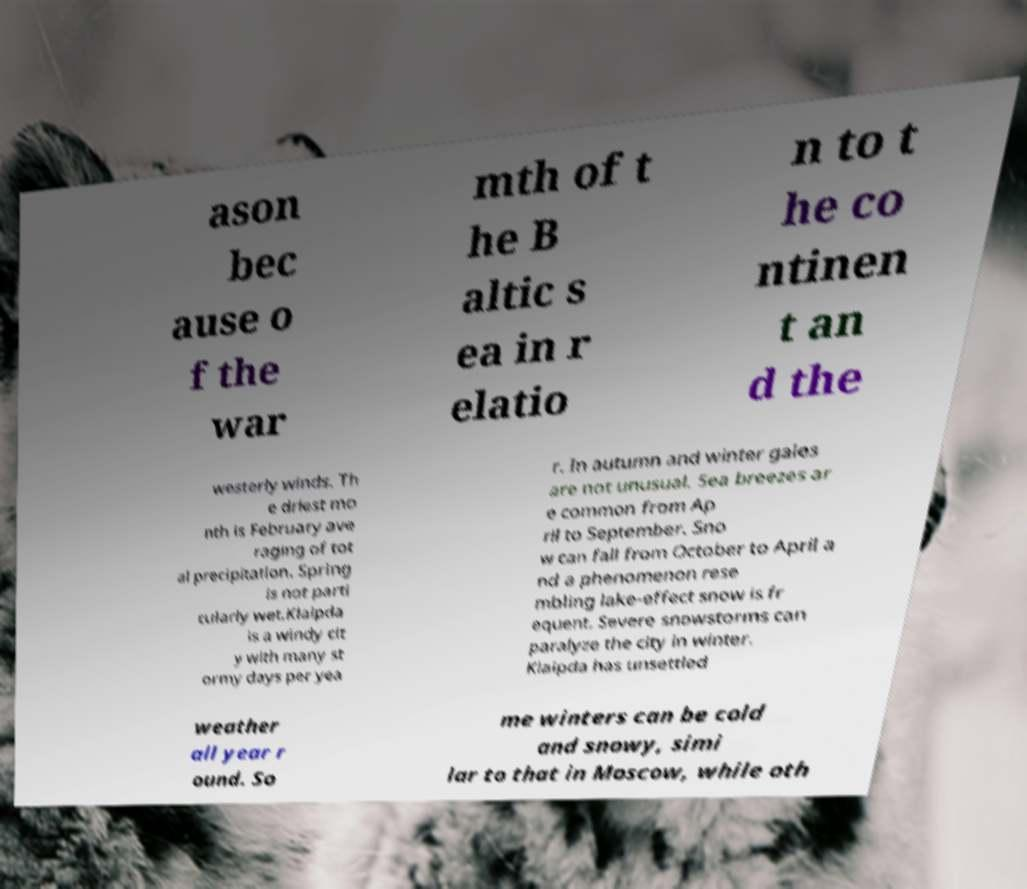Could you extract and type out the text from this image? ason bec ause o f the war mth of t he B altic s ea in r elatio n to t he co ntinen t an d the westerly winds. Th e driest mo nth is February ave raging of tot al precipitation. Spring is not parti cularly wet.Klaipda is a windy cit y with many st ormy days per yea r. In autumn and winter gales are not unusual. Sea breezes ar e common from Ap ril to September. Sno w can fall from October to April a nd a phenomenon rese mbling lake-effect snow is fr equent. Severe snowstorms can paralyze the city in winter. Klaipda has unsettled weather all year r ound. So me winters can be cold and snowy, simi lar to that in Moscow, while oth 